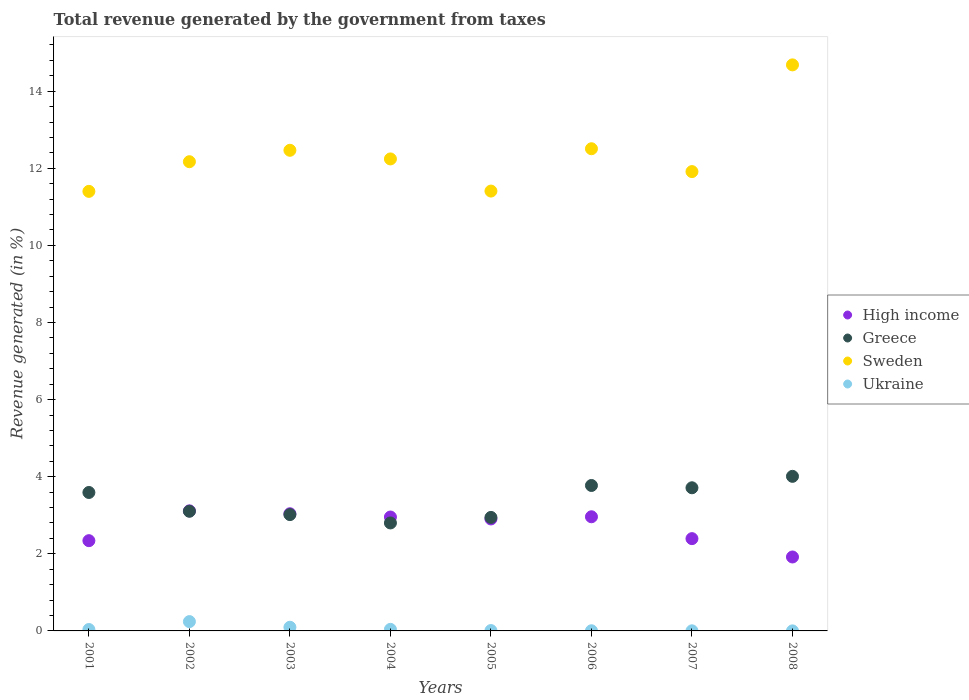How many different coloured dotlines are there?
Ensure brevity in your answer.  4. Is the number of dotlines equal to the number of legend labels?
Make the answer very short. Yes. What is the total revenue generated in High income in 2006?
Offer a very short reply. 2.96. Across all years, what is the maximum total revenue generated in Ukraine?
Make the answer very short. 0.24. Across all years, what is the minimum total revenue generated in Ukraine?
Ensure brevity in your answer.  0. In which year was the total revenue generated in Greece minimum?
Offer a very short reply. 2004. What is the total total revenue generated in Ukraine in the graph?
Ensure brevity in your answer.  0.43. What is the difference between the total revenue generated in Greece in 2002 and that in 2003?
Provide a succinct answer. 0.09. What is the difference between the total revenue generated in Greece in 2003 and the total revenue generated in Sweden in 2005?
Offer a terse response. -8.39. What is the average total revenue generated in Ukraine per year?
Keep it short and to the point. 0.05. In the year 2002, what is the difference between the total revenue generated in Greece and total revenue generated in Ukraine?
Your answer should be very brief. 2.86. In how many years, is the total revenue generated in Sweden greater than 8 %?
Give a very brief answer. 8. What is the ratio of the total revenue generated in Sweden in 2004 to that in 2005?
Provide a short and direct response. 1.07. Is the total revenue generated in High income in 2002 less than that in 2003?
Keep it short and to the point. No. Is the difference between the total revenue generated in Greece in 2002 and 2003 greater than the difference between the total revenue generated in Ukraine in 2002 and 2003?
Make the answer very short. No. What is the difference between the highest and the second highest total revenue generated in Ukraine?
Provide a succinct answer. 0.15. What is the difference between the highest and the lowest total revenue generated in Ukraine?
Offer a very short reply. 0.24. In how many years, is the total revenue generated in High income greater than the average total revenue generated in High income taken over all years?
Give a very brief answer. 5. Is it the case that in every year, the sum of the total revenue generated in Ukraine and total revenue generated in Greece  is greater than the sum of total revenue generated in High income and total revenue generated in Sweden?
Offer a very short reply. Yes. Is it the case that in every year, the sum of the total revenue generated in High income and total revenue generated in Ukraine  is greater than the total revenue generated in Greece?
Your response must be concise. No. Does the total revenue generated in Greece monotonically increase over the years?
Ensure brevity in your answer.  No. Is the total revenue generated in Greece strictly greater than the total revenue generated in Sweden over the years?
Give a very brief answer. No. Is the total revenue generated in Ukraine strictly less than the total revenue generated in Greece over the years?
Your response must be concise. Yes. How many years are there in the graph?
Offer a very short reply. 8. Does the graph contain any zero values?
Your answer should be very brief. No. How many legend labels are there?
Offer a very short reply. 4. How are the legend labels stacked?
Keep it short and to the point. Vertical. What is the title of the graph?
Give a very brief answer. Total revenue generated by the government from taxes. Does "India" appear as one of the legend labels in the graph?
Ensure brevity in your answer.  No. What is the label or title of the X-axis?
Your answer should be very brief. Years. What is the label or title of the Y-axis?
Offer a very short reply. Revenue generated (in %). What is the Revenue generated (in %) in High income in 2001?
Offer a terse response. 2.34. What is the Revenue generated (in %) of Greece in 2001?
Offer a very short reply. 3.59. What is the Revenue generated (in %) of Sweden in 2001?
Your answer should be very brief. 11.4. What is the Revenue generated (in %) in Ukraine in 2001?
Your response must be concise. 0.04. What is the Revenue generated (in %) in High income in 2002?
Ensure brevity in your answer.  3.11. What is the Revenue generated (in %) of Greece in 2002?
Keep it short and to the point. 3.1. What is the Revenue generated (in %) of Sweden in 2002?
Offer a very short reply. 12.17. What is the Revenue generated (in %) of Ukraine in 2002?
Offer a terse response. 0.24. What is the Revenue generated (in %) of High income in 2003?
Provide a succinct answer. 3.04. What is the Revenue generated (in %) in Greece in 2003?
Offer a terse response. 3.02. What is the Revenue generated (in %) in Sweden in 2003?
Provide a short and direct response. 12.47. What is the Revenue generated (in %) in Ukraine in 2003?
Provide a succinct answer. 0.1. What is the Revenue generated (in %) of High income in 2004?
Keep it short and to the point. 2.95. What is the Revenue generated (in %) in Greece in 2004?
Keep it short and to the point. 2.8. What is the Revenue generated (in %) in Sweden in 2004?
Provide a short and direct response. 12.24. What is the Revenue generated (in %) of Ukraine in 2004?
Offer a very short reply. 0.04. What is the Revenue generated (in %) of High income in 2005?
Ensure brevity in your answer.  2.9. What is the Revenue generated (in %) in Greece in 2005?
Provide a succinct answer. 2.94. What is the Revenue generated (in %) of Sweden in 2005?
Your response must be concise. 11.41. What is the Revenue generated (in %) of Ukraine in 2005?
Provide a short and direct response. 0.01. What is the Revenue generated (in %) in High income in 2006?
Your answer should be very brief. 2.96. What is the Revenue generated (in %) in Greece in 2006?
Give a very brief answer. 3.77. What is the Revenue generated (in %) of Sweden in 2006?
Offer a very short reply. 12.51. What is the Revenue generated (in %) of Ukraine in 2006?
Your response must be concise. 0. What is the Revenue generated (in %) of High income in 2007?
Ensure brevity in your answer.  2.39. What is the Revenue generated (in %) of Greece in 2007?
Your answer should be very brief. 3.71. What is the Revenue generated (in %) of Sweden in 2007?
Make the answer very short. 11.91. What is the Revenue generated (in %) in Ukraine in 2007?
Provide a short and direct response. 0. What is the Revenue generated (in %) in High income in 2008?
Ensure brevity in your answer.  1.92. What is the Revenue generated (in %) in Greece in 2008?
Provide a succinct answer. 4.01. What is the Revenue generated (in %) of Sweden in 2008?
Provide a succinct answer. 14.68. What is the Revenue generated (in %) in Ukraine in 2008?
Keep it short and to the point. 0. Across all years, what is the maximum Revenue generated (in %) of High income?
Provide a succinct answer. 3.11. Across all years, what is the maximum Revenue generated (in %) of Greece?
Offer a very short reply. 4.01. Across all years, what is the maximum Revenue generated (in %) in Sweden?
Your answer should be very brief. 14.68. Across all years, what is the maximum Revenue generated (in %) of Ukraine?
Provide a succinct answer. 0.24. Across all years, what is the minimum Revenue generated (in %) in High income?
Make the answer very short. 1.92. Across all years, what is the minimum Revenue generated (in %) in Greece?
Provide a short and direct response. 2.8. Across all years, what is the minimum Revenue generated (in %) in Sweden?
Ensure brevity in your answer.  11.4. Across all years, what is the minimum Revenue generated (in %) in Ukraine?
Your answer should be very brief. 0. What is the total Revenue generated (in %) of High income in the graph?
Give a very brief answer. 21.63. What is the total Revenue generated (in %) of Greece in the graph?
Offer a very short reply. 26.95. What is the total Revenue generated (in %) in Sweden in the graph?
Ensure brevity in your answer.  98.8. What is the total Revenue generated (in %) of Ukraine in the graph?
Offer a very short reply. 0.43. What is the difference between the Revenue generated (in %) in High income in 2001 and that in 2002?
Offer a very short reply. -0.77. What is the difference between the Revenue generated (in %) in Greece in 2001 and that in 2002?
Your answer should be very brief. 0.49. What is the difference between the Revenue generated (in %) in Sweden in 2001 and that in 2002?
Your response must be concise. -0.77. What is the difference between the Revenue generated (in %) in Ukraine in 2001 and that in 2002?
Offer a very short reply. -0.21. What is the difference between the Revenue generated (in %) in High income in 2001 and that in 2003?
Offer a very short reply. -0.7. What is the difference between the Revenue generated (in %) in Greece in 2001 and that in 2003?
Give a very brief answer. 0.57. What is the difference between the Revenue generated (in %) of Sweden in 2001 and that in 2003?
Offer a terse response. -1.07. What is the difference between the Revenue generated (in %) in Ukraine in 2001 and that in 2003?
Give a very brief answer. -0.06. What is the difference between the Revenue generated (in %) of High income in 2001 and that in 2004?
Make the answer very short. -0.61. What is the difference between the Revenue generated (in %) of Greece in 2001 and that in 2004?
Keep it short and to the point. 0.79. What is the difference between the Revenue generated (in %) in Sweden in 2001 and that in 2004?
Offer a terse response. -0.84. What is the difference between the Revenue generated (in %) in Ukraine in 2001 and that in 2004?
Offer a terse response. -0. What is the difference between the Revenue generated (in %) in High income in 2001 and that in 2005?
Your response must be concise. -0.56. What is the difference between the Revenue generated (in %) of Greece in 2001 and that in 2005?
Make the answer very short. 0.65. What is the difference between the Revenue generated (in %) in Sweden in 2001 and that in 2005?
Offer a terse response. -0.01. What is the difference between the Revenue generated (in %) in Ukraine in 2001 and that in 2005?
Make the answer very short. 0.03. What is the difference between the Revenue generated (in %) in High income in 2001 and that in 2006?
Ensure brevity in your answer.  -0.62. What is the difference between the Revenue generated (in %) of Greece in 2001 and that in 2006?
Keep it short and to the point. -0.18. What is the difference between the Revenue generated (in %) in Sweden in 2001 and that in 2006?
Provide a short and direct response. -1.11. What is the difference between the Revenue generated (in %) in Ukraine in 2001 and that in 2006?
Offer a terse response. 0.03. What is the difference between the Revenue generated (in %) of High income in 2001 and that in 2007?
Keep it short and to the point. -0.05. What is the difference between the Revenue generated (in %) in Greece in 2001 and that in 2007?
Your answer should be compact. -0.12. What is the difference between the Revenue generated (in %) in Sweden in 2001 and that in 2007?
Give a very brief answer. -0.51. What is the difference between the Revenue generated (in %) in Ukraine in 2001 and that in 2007?
Offer a terse response. 0.03. What is the difference between the Revenue generated (in %) of High income in 2001 and that in 2008?
Give a very brief answer. 0.42. What is the difference between the Revenue generated (in %) of Greece in 2001 and that in 2008?
Ensure brevity in your answer.  -0.42. What is the difference between the Revenue generated (in %) of Sweden in 2001 and that in 2008?
Your response must be concise. -3.28. What is the difference between the Revenue generated (in %) of Ukraine in 2001 and that in 2008?
Your answer should be compact. 0.04. What is the difference between the Revenue generated (in %) in High income in 2002 and that in 2003?
Your answer should be very brief. 0.08. What is the difference between the Revenue generated (in %) of Greece in 2002 and that in 2003?
Your answer should be compact. 0.09. What is the difference between the Revenue generated (in %) of Sweden in 2002 and that in 2003?
Keep it short and to the point. -0.3. What is the difference between the Revenue generated (in %) of Ukraine in 2002 and that in 2003?
Provide a succinct answer. 0.15. What is the difference between the Revenue generated (in %) in High income in 2002 and that in 2004?
Provide a short and direct response. 0.16. What is the difference between the Revenue generated (in %) of Greece in 2002 and that in 2004?
Ensure brevity in your answer.  0.3. What is the difference between the Revenue generated (in %) of Sweden in 2002 and that in 2004?
Offer a terse response. -0.07. What is the difference between the Revenue generated (in %) in Ukraine in 2002 and that in 2004?
Give a very brief answer. 0.2. What is the difference between the Revenue generated (in %) in High income in 2002 and that in 2005?
Offer a very short reply. 0.21. What is the difference between the Revenue generated (in %) in Greece in 2002 and that in 2005?
Give a very brief answer. 0.16. What is the difference between the Revenue generated (in %) of Sweden in 2002 and that in 2005?
Ensure brevity in your answer.  0.76. What is the difference between the Revenue generated (in %) of Ukraine in 2002 and that in 2005?
Your answer should be compact. 0.23. What is the difference between the Revenue generated (in %) of High income in 2002 and that in 2006?
Your response must be concise. 0.15. What is the difference between the Revenue generated (in %) of Greece in 2002 and that in 2006?
Offer a very short reply. -0.67. What is the difference between the Revenue generated (in %) in Sweden in 2002 and that in 2006?
Ensure brevity in your answer.  -0.34. What is the difference between the Revenue generated (in %) of Ukraine in 2002 and that in 2006?
Keep it short and to the point. 0.24. What is the difference between the Revenue generated (in %) of High income in 2002 and that in 2007?
Provide a succinct answer. 0.72. What is the difference between the Revenue generated (in %) in Greece in 2002 and that in 2007?
Provide a short and direct response. -0.61. What is the difference between the Revenue generated (in %) in Sweden in 2002 and that in 2007?
Your answer should be very brief. 0.26. What is the difference between the Revenue generated (in %) of Ukraine in 2002 and that in 2007?
Your answer should be very brief. 0.24. What is the difference between the Revenue generated (in %) in High income in 2002 and that in 2008?
Your answer should be very brief. 1.2. What is the difference between the Revenue generated (in %) in Greece in 2002 and that in 2008?
Provide a succinct answer. -0.91. What is the difference between the Revenue generated (in %) in Sweden in 2002 and that in 2008?
Provide a short and direct response. -2.51. What is the difference between the Revenue generated (in %) in Ukraine in 2002 and that in 2008?
Keep it short and to the point. 0.24. What is the difference between the Revenue generated (in %) of High income in 2003 and that in 2004?
Keep it short and to the point. 0.09. What is the difference between the Revenue generated (in %) of Greece in 2003 and that in 2004?
Provide a succinct answer. 0.22. What is the difference between the Revenue generated (in %) in Sweden in 2003 and that in 2004?
Offer a terse response. 0.22. What is the difference between the Revenue generated (in %) in Ukraine in 2003 and that in 2004?
Keep it short and to the point. 0.05. What is the difference between the Revenue generated (in %) of High income in 2003 and that in 2005?
Your answer should be compact. 0.14. What is the difference between the Revenue generated (in %) of Greece in 2003 and that in 2005?
Provide a succinct answer. 0.07. What is the difference between the Revenue generated (in %) of Sweden in 2003 and that in 2005?
Your answer should be very brief. 1.06. What is the difference between the Revenue generated (in %) of Ukraine in 2003 and that in 2005?
Keep it short and to the point. 0.09. What is the difference between the Revenue generated (in %) in High income in 2003 and that in 2006?
Provide a succinct answer. 0.08. What is the difference between the Revenue generated (in %) in Greece in 2003 and that in 2006?
Provide a succinct answer. -0.76. What is the difference between the Revenue generated (in %) in Sweden in 2003 and that in 2006?
Your answer should be compact. -0.04. What is the difference between the Revenue generated (in %) of Ukraine in 2003 and that in 2006?
Keep it short and to the point. 0.09. What is the difference between the Revenue generated (in %) in High income in 2003 and that in 2007?
Your answer should be very brief. 0.65. What is the difference between the Revenue generated (in %) in Greece in 2003 and that in 2007?
Provide a succinct answer. -0.7. What is the difference between the Revenue generated (in %) of Sweden in 2003 and that in 2007?
Provide a short and direct response. 0.55. What is the difference between the Revenue generated (in %) of Ukraine in 2003 and that in 2007?
Ensure brevity in your answer.  0.09. What is the difference between the Revenue generated (in %) of High income in 2003 and that in 2008?
Ensure brevity in your answer.  1.12. What is the difference between the Revenue generated (in %) in Greece in 2003 and that in 2008?
Your answer should be compact. -0.99. What is the difference between the Revenue generated (in %) in Sweden in 2003 and that in 2008?
Ensure brevity in your answer.  -2.22. What is the difference between the Revenue generated (in %) of Ukraine in 2003 and that in 2008?
Your response must be concise. 0.09. What is the difference between the Revenue generated (in %) of High income in 2004 and that in 2005?
Ensure brevity in your answer.  0.05. What is the difference between the Revenue generated (in %) of Greece in 2004 and that in 2005?
Offer a terse response. -0.14. What is the difference between the Revenue generated (in %) in Sweden in 2004 and that in 2005?
Your response must be concise. 0.83. What is the difference between the Revenue generated (in %) in Ukraine in 2004 and that in 2005?
Your answer should be very brief. 0.03. What is the difference between the Revenue generated (in %) in High income in 2004 and that in 2006?
Keep it short and to the point. -0.01. What is the difference between the Revenue generated (in %) in Greece in 2004 and that in 2006?
Offer a terse response. -0.97. What is the difference between the Revenue generated (in %) of Sweden in 2004 and that in 2006?
Ensure brevity in your answer.  -0.26. What is the difference between the Revenue generated (in %) in Ukraine in 2004 and that in 2006?
Give a very brief answer. 0.04. What is the difference between the Revenue generated (in %) in High income in 2004 and that in 2007?
Provide a short and direct response. 0.56. What is the difference between the Revenue generated (in %) in Greece in 2004 and that in 2007?
Your answer should be very brief. -0.91. What is the difference between the Revenue generated (in %) of Sweden in 2004 and that in 2007?
Your answer should be compact. 0.33. What is the difference between the Revenue generated (in %) of Ukraine in 2004 and that in 2007?
Give a very brief answer. 0.04. What is the difference between the Revenue generated (in %) of High income in 2004 and that in 2008?
Your response must be concise. 1.04. What is the difference between the Revenue generated (in %) in Greece in 2004 and that in 2008?
Keep it short and to the point. -1.21. What is the difference between the Revenue generated (in %) in Sweden in 2004 and that in 2008?
Offer a terse response. -2.44. What is the difference between the Revenue generated (in %) in Ukraine in 2004 and that in 2008?
Give a very brief answer. 0.04. What is the difference between the Revenue generated (in %) of High income in 2005 and that in 2006?
Your response must be concise. -0.06. What is the difference between the Revenue generated (in %) of Greece in 2005 and that in 2006?
Offer a terse response. -0.83. What is the difference between the Revenue generated (in %) of Sweden in 2005 and that in 2006?
Keep it short and to the point. -1.1. What is the difference between the Revenue generated (in %) in Ukraine in 2005 and that in 2006?
Your answer should be compact. 0.01. What is the difference between the Revenue generated (in %) in High income in 2005 and that in 2007?
Offer a very short reply. 0.51. What is the difference between the Revenue generated (in %) in Greece in 2005 and that in 2007?
Make the answer very short. -0.77. What is the difference between the Revenue generated (in %) of Sweden in 2005 and that in 2007?
Provide a succinct answer. -0.51. What is the difference between the Revenue generated (in %) of Ukraine in 2005 and that in 2007?
Provide a short and direct response. 0.01. What is the difference between the Revenue generated (in %) in High income in 2005 and that in 2008?
Ensure brevity in your answer.  0.99. What is the difference between the Revenue generated (in %) of Greece in 2005 and that in 2008?
Offer a terse response. -1.07. What is the difference between the Revenue generated (in %) of Sweden in 2005 and that in 2008?
Make the answer very short. -3.27. What is the difference between the Revenue generated (in %) of Ukraine in 2005 and that in 2008?
Your answer should be very brief. 0.01. What is the difference between the Revenue generated (in %) of High income in 2006 and that in 2007?
Offer a terse response. 0.57. What is the difference between the Revenue generated (in %) in Greece in 2006 and that in 2007?
Provide a succinct answer. 0.06. What is the difference between the Revenue generated (in %) in Sweden in 2006 and that in 2007?
Your answer should be compact. 0.59. What is the difference between the Revenue generated (in %) in Ukraine in 2006 and that in 2007?
Your response must be concise. 0. What is the difference between the Revenue generated (in %) in High income in 2006 and that in 2008?
Give a very brief answer. 1.04. What is the difference between the Revenue generated (in %) in Greece in 2006 and that in 2008?
Your response must be concise. -0.24. What is the difference between the Revenue generated (in %) in Sweden in 2006 and that in 2008?
Make the answer very short. -2.18. What is the difference between the Revenue generated (in %) in Ukraine in 2006 and that in 2008?
Offer a terse response. 0. What is the difference between the Revenue generated (in %) of High income in 2007 and that in 2008?
Keep it short and to the point. 0.48. What is the difference between the Revenue generated (in %) of Greece in 2007 and that in 2008?
Ensure brevity in your answer.  -0.3. What is the difference between the Revenue generated (in %) of Sweden in 2007 and that in 2008?
Keep it short and to the point. -2.77. What is the difference between the Revenue generated (in %) in Ukraine in 2007 and that in 2008?
Ensure brevity in your answer.  0. What is the difference between the Revenue generated (in %) of High income in 2001 and the Revenue generated (in %) of Greece in 2002?
Your answer should be compact. -0.76. What is the difference between the Revenue generated (in %) in High income in 2001 and the Revenue generated (in %) in Sweden in 2002?
Keep it short and to the point. -9.83. What is the difference between the Revenue generated (in %) in High income in 2001 and the Revenue generated (in %) in Ukraine in 2002?
Make the answer very short. 2.1. What is the difference between the Revenue generated (in %) of Greece in 2001 and the Revenue generated (in %) of Sweden in 2002?
Your response must be concise. -8.58. What is the difference between the Revenue generated (in %) in Greece in 2001 and the Revenue generated (in %) in Ukraine in 2002?
Provide a succinct answer. 3.35. What is the difference between the Revenue generated (in %) of Sweden in 2001 and the Revenue generated (in %) of Ukraine in 2002?
Keep it short and to the point. 11.16. What is the difference between the Revenue generated (in %) in High income in 2001 and the Revenue generated (in %) in Greece in 2003?
Your answer should be compact. -0.68. What is the difference between the Revenue generated (in %) of High income in 2001 and the Revenue generated (in %) of Sweden in 2003?
Your response must be concise. -10.13. What is the difference between the Revenue generated (in %) of High income in 2001 and the Revenue generated (in %) of Ukraine in 2003?
Your answer should be very brief. 2.25. What is the difference between the Revenue generated (in %) of Greece in 2001 and the Revenue generated (in %) of Sweden in 2003?
Your answer should be very brief. -8.88. What is the difference between the Revenue generated (in %) of Greece in 2001 and the Revenue generated (in %) of Ukraine in 2003?
Make the answer very short. 3.5. What is the difference between the Revenue generated (in %) in Sweden in 2001 and the Revenue generated (in %) in Ukraine in 2003?
Ensure brevity in your answer.  11.31. What is the difference between the Revenue generated (in %) in High income in 2001 and the Revenue generated (in %) in Greece in 2004?
Offer a terse response. -0.46. What is the difference between the Revenue generated (in %) in High income in 2001 and the Revenue generated (in %) in Sweden in 2004?
Keep it short and to the point. -9.9. What is the difference between the Revenue generated (in %) of High income in 2001 and the Revenue generated (in %) of Ukraine in 2004?
Your response must be concise. 2.3. What is the difference between the Revenue generated (in %) in Greece in 2001 and the Revenue generated (in %) in Sweden in 2004?
Your answer should be compact. -8.65. What is the difference between the Revenue generated (in %) of Greece in 2001 and the Revenue generated (in %) of Ukraine in 2004?
Give a very brief answer. 3.55. What is the difference between the Revenue generated (in %) in Sweden in 2001 and the Revenue generated (in %) in Ukraine in 2004?
Make the answer very short. 11.36. What is the difference between the Revenue generated (in %) in High income in 2001 and the Revenue generated (in %) in Greece in 2005?
Ensure brevity in your answer.  -0.6. What is the difference between the Revenue generated (in %) in High income in 2001 and the Revenue generated (in %) in Sweden in 2005?
Offer a terse response. -9.07. What is the difference between the Revenue generated (in %) of High income in 2001 and the Revenue generated (in %) of Ukraine in 2005?
Provide a short and direct response. 2.33. What is the difference between the Revenue generated (in %) of Greece in 2001 and the Revenue generated (in %) of Sweden in 2005?
Make the answer very short. -7.82. What is the difference between the Revenue generated (in %) in Greece in 2001 and the Revenue generated (in %) in Ukraine in 2005?
Offer a terse response. 3.58. What is the difference between the Revenue generated (in %) in Sweden in 2001 and the Revenue generated (in %) in Ukraine in 2005?
Offer a very short reply. 11.39. What is the difference between the Revenue generated (in %) of High income in 2001 and the Revenue generated (in %) of Greece in 2006?
Your response must be concise. -1.43. What is the difference between the Revenue generated (in %) of High income in 2001 and the Revenue generated (in %) of Sweden in 2006?
Your response must be concise. -10.17. What is the difference between the Revenue generated (in %) of High income in 2001 and the Revenue generated (in %) of Ukraine in 2006?
Your answer should be compact. 2.34. What is the difference between the Revenue generated (in %) in Greece in 2001 and the Revenue generated (in %) in Sweden in 2006?
Your response must be concise. -8.92. What is the difference between the Revenue generated (in %) of Greece in 2001 and the Revenue generated (in %) of Ukraine in 2006?
Provide a short and direct response. 3.59. What is the difference between the Revenue generated (in %) of Sweden in 2001 and the Revenue generated (in %) of Ukraine in 2006?
Offer a very short reply. 11.4. What is the difference between the Revenue generated (in %) of High income in 2001 and the Revenue generated (in %) of Greece in 2007?
Provide a succinct answer. -1.37. What is the difference between the Revenue generated (in %) in High income in 2001 and the Revenue generated (in %) in Sweden in 2007?
Offer a terse response. -9.57. What is the difference between the Revenue generated (in %) of High income in 2001 and the Revenue generated (in %) of Ukraine in 2007?
Provide a succinct answer. 2.34. What is the difference between the Revenue generated (in %) in Greece in 2001 and the Revenue generated (in %) in Sweden in 2007?
Your response must be concise. -8.32. What is the difference between the Revenue generated (in %) in Greece in 2001 and the Revenue generated (in %) in Ukraine in 2007?
Your response must be concise. 3.59. What is the difference between the Revenue generated (in %) in Sweden in 2001 and the Revenue generated (in %) in Ukraine in 2007?
Keep it short and to the point. 11.4. What is the difference between the Revenue generated (in %) of High income in 2001 and the Revenue generated (in %) of Greece in 2008?
Your response must be concise. -1.67. What is the difference between the Revenue generated (in %) of High income in 2001 and the Revenue generated (in %) of Sweden in 2008?
Offer a very short reply. -12.34. What is the difference between the Revenue generated (in %) of High income in 2001 and the Revenue generated (in %) of Ukraine in 2008?
Keep it short and to the point. 2.34. What is the difference between the Revenue generated (in %) of Greece in 2001 and the Revenue generated (in %) of Sweden in 2008?
Your response must be concise. -11.09. What is the difference between the Revenue generated (in %) of Greece in 2001 and the Revenue generated (in %) of Ukraine in 2008?
Your answer should be very brief. 3.59. What is the difference between the Revenue generated (in %) in Sweden in 2001 and the Revenue generated (in %) in Ukraine in 2008?
Make the answer very short. 11.4. What is the difference between the Revenue generated (in %) of High income in 2002 and the Revenue generated (in %) of Greece in 2003?
Ensure brevity in your answer.  0.1. What is the difference between the Revenue generated (in %) of High income in 2002 and the Revenue generated (in %) of Sweden in 2003?
Your answer should be very brief. -9.35. What is the difference between the Revenue generated (in %) of High income in 2002 and the Revenue generated (in %) of Ukraine in 2003?
Offer a terse response. 3.02. What is the difference between the Revenue generated (in %) in Greece in 2002 and the Revenue generated (in %) in Sweden in 2003?
Offer a terse response. -9.36. What is the difference between the Revenue generated (in %) in Greece in 2002 and the Revenue generated (in %) in Ukraine in 2003?
Keep it short and to the point. 3.01. What is the difference between the Revenue generated (in %) in Sweden in 2002 and the Revenue generated (in %) in Ukraine in 2003?
Offer a very short reply. 12.08. What is the difference between the Revenue generated (in %) of High income in 2002 and the Revenue generated (in %) of Greece in 2004?
Keep it short and to the point. 0.31. What is the difference between the Revenue generated (in %) in High income in 2002 and the Revenue generated (in %) in Sweden in 2004?
Your answer should be compact. -9.13. What is the difference between the Revenue generated (in %) of High income in 2002 and the Revenue generated (in %) of Ukraine in 2004?
Your answer should be very brief. 3.07. What is the difference between the Revenue generated (in %) of Greece in 2002 and the Revenue generated (in %) of Sweden in 2004?
Offer a very short reply. -9.14. What is the difference between the Revenue generated (in %) of Greece in 2002 and the Revenue generated (in %) of Ukraine in 2004?
Your response must be concise. 3.06. What is the difference between the Revenue generated (in %) of Sweden in 2002 and the Revenue generated (in %) of Ukraine in 2004?
Provide a short and direct response. 12.13. What is the difference between the Revenue generated (in %) of High income in 2002 and the Revenue generated (in %) of Greece in 2005?
Ensure brevity in your answer.  0.17. What is the difference between the Revenue generated (in %) of High income in 2002 and the Revenue generated (in %) of Sweden in 2005?
Provide a succinct answer. -8.29. What is the difference between the Revenue generated (in %) in High income in 2002 and the Revenue generated (in %) in Ukraine in 2005?
Keep it short and to the point. 3.11. What is the difference between the Revenue generated (in %) of Greece in 2002 and the Revenue generated (in %) of Sweden in 2005?
Offer a very short reply. -8.31. What is the difference between the Revenue generated (in %) of Greece in 2002 and the Revenue generated (in %) of Ukraine in 2005?
Make the answer very short. 3.09. What is the difference between the Revenue generated (in %) of Sweden in 2002 and the Revenue generated (in %) of Ukraine in 2005?
Keep it short and to the point. 12.16. What is the difference between the Revenue generated (in %) of High income in 2002 and the Revenue generated (in %) of Greece in 2006?
Ensure brevity in your answer.  -0.66. What is the difference between the Revenue generated (in %) of High income in 2002 and the Revenue generated (in %) of Sweden in 2006?
Your answer should be compact. -9.39. What is the difference between the Revenue generated (in %) of High income in 2002 and the Revenue generated (in %) of Ukraine in 2006?
Your answer should be very brief. 3.11. What is the difference between the Revenue generated (in %) in Greece in 2002 and the Revenue generated (in %) in Sweden in 2006?
Ensure brevity in your answer.  -9.4. What is the difference between the Revenue generated (in %) in Greece in 2002 and the Revenue generated (in %) in Ukraine in 2006?
Offer a terse response. 3.1. What is the difference between the Revenue generated (in %) in Sweden in 2002 and the Revenue generated (in %) in Ukraine in 2006?
Ensure brevity in your answer.  12.17. What is the difference between the Revenue generated (in %) of High income in 2002 and the Revenue generated (in %) of Greece in 2007?
Ensure brevity in your answer.  -0.6. What is the difference between the Revenue generated (in %) in High income in 2002 and the Revenue generated (in %) in Sweden in 2007?
Provide a succinct answer. -8.8. What is the difference between the Revenue generated (in %) in High income in 2002 and the Revenue generated (in %) in Ukraine in 2007?
Provide a short and direct response. 3.11. What is the difference between the Revenue generated (in %) in Greece in 2002 and the Revenue generated (in %) in Sweden in 2007?
Offer a very short reply. -8.81. What is the difference between the Revenue generated (in %) in Greece in 2002 and the Revenue generated (in %) in Ukraine in 2007?
Ensure brevity in your answer.  3.1. What is the difference between the Revenue generated (in %) of Sweden in 2002 and the Revenue generated (in %) of Ukraine in 2007?
Keep it short and to the point. 12.17. What is the difference between the Revenue generated (in %) in High income in 2002 and the Revenue generated (in %) in Greece in 2008?
Provide a short and direct response. -0.9. What is the difference between the Revenue generated (in %) in High income in 2002 and the Revenue generated (in %) in Sweden in 2008?
Keep it short and to the point. -11.57. What is the difference between the Revenue generated (in %) in High income in 2002 and the Revenue generated (in %) in Ukraine in 2008?
Provide a succinct answer. 3.11. What is the difference between the Revenue generated (in %) in Greece in 2002 and the Revenue generated (in %) in Sweden in 2008?
Give a very brief answer. -11.58. What is the difference between the Revenue generated (in %) of Greece in 2002 and the Revenue generated (in %) of Ukraine in 2008?
Ensure brevity in your answer.  3.1. What is the difference between the Revenue generated (in %) of Sweden in 2002 and the Revenue generated (in %) of Ukraine in 2008?
Your answer should be compact. 12.17. What is the difference between the Revenue generated (in %) in High income in 2003 and the Revenue generated (in %) in Greece in 2004?
Make the answer very short. 0.24. What is the difference between the Revenue generated (in %) in High income in 2003 and the Revenue generated (in %) in Sweden in 2004?
Provide a short and direct response. -9.2. What is the difference between the Revenue generated (in %) of High income in 2003 and the Revenue generated (in %) of Ukraine in 2004?
Make the answer very short. 3. What is the difference between the Revenue generated (in %) of Greece in 2003 and the Revenue generated (in %) of Sweden in 2004?
Ensure brevity in your answer.  -9.23. What is the difference between the Revenue generated (in %) in Greece in 2003 and the Revenue generated (in %) in Ukraine in 2004?
Your answer should be compact. 2.98. What is the difference between the Revenue generated (in %) in Sweden in 2003 and the Revenue generated (in %) in Ukraine in 2004?
Your response must be concise. 12.43. What is the difference between the Revenue generated (in %) of High income in 2003 and the Revenue generated (in %) of Greece in 2005?
Your answer should be compact. 0.1. What is the difference between the Revenue generated (in %) of High income in 2003 and the Revenue generated (in %) of Sweden in 2005?
Keep it short and to the point. -8.37. What is the difference between the Revenue generated (in %) of High income in 2003 and the Revenue generated (in %) of Ukraine in 2005?
Provide a short and direct response. 3.03. What is the difference between the Revenue generated (in %) in Greece in 2003 and the Revenue generated (in %) in Sweden in 2005?
Your answer should be compact. -8.39. What is the difference between the Revenue generated (in %) of Greece in 2003 and the Revenue generated (in %) of Ukraine in 2005?
Your answer should be very brief. 3.01. What is the difference between the Revenue generated (in %) in Sweden in 2003 and the Revenue generated (in %) in Ukraine in 2005?
Your answer should be very brief. 12.46. What is the difference between the Revenue generated (in %) in High income in 2003 and the Revenue generated (in %) in Greece in 2006?
Ensure brevity in your answer.  -0.73. What is the difference between the Revenue generated (in %) in High income in 2003 and the Revenue generated (in %) in Sweden in 2006?
Your response must be concise. -9.47. What is the difference between the Revenue generated (in %) in High income in 2003 and the Revenue generated (in %) in Ukraine in 2006?
Your response must be concise. 3.04. What is the difference between the Revenue generated (in %) of Greece in 2003 and the Revenue generated (in %) of Sweden in 2006?
Offer a terse response. -9.49. What is the difference between the Revenue generated (in %) of Greece in 2003 and the Revenue generated (in %) of Ukraine in 2006?
Ensure brevity in your answer.  3.01. What is the difference between the Revenue generated (in %) in Sweden in 2003 and the Revenue generated (in %) in Ukraine in 2006?
Your answer should be compact. 12.46. What is the difference between the Revenue generated (in %) of High income in 2003 and the Revenue generated (in %) of Greece in 2007?
Provide a succinct answer. -0.67. What is the difference between the Revenue generated (in %) in High income in 2003 and the Revenue generated (in %) in Sweden in 2007?
Your answer should be very brief. -8.87. What is the difference between the Revenue generated (in %) in High income in 2003 and the Revenue generated (in %) in Ukraine in 2007?
Provide a succinct answer. 3.04. What is the difference between the Revenue generated (in %) in Greece in 2003 and the Revenue generated (in %) in Sweden in 2007?
Keep it short and to the point. -8.9. What is the difference between the Revenue generated (in %) in Greece in 2003 and the Revenue generated (in %) in Ukraine in 2007?
Make the answer very short. 3.01. What is the difference between the Revenue generated (in %) of Sweden in 2003 and the Revenue generated (in %) of Ukraine in 2007?
Your answer should be compact. 12.46. What is the difference between the Revenue generated (in %) of High income in 2003 and the Revenue generated (in %) of Greece in 2008?
Offer a very short reply. -0.97. What is the difference between the Revenue generated (in %) in High income in 2003 and the Revenue generated (in %) in Sweden in 2008?
Make the answer very short. -11.64. What is the difference between the Revenue generated (in %) in High income in 2003 and the Revenue generated (in %) in Ukraine in 2008?
Offer a very short reply. 3.04. What is the difference between the Revenue generated (in %) in Greece in 2003 and the Revenue generated (in %) in Sweden in 2008?
Your response must be concise. -11.67. What is the difference between the Revenue generated (in %) of Greece in 2003 and the Revenue generated (in %) of Ukraine in 2008?
Ensure brevity in your answer.  3.02. What is the difference between the Revenue generated (in %) of Sweden in 2003 and the Revenue generated (in %) of Ukraine in 2008?
Ensure brevity in your answer.  12.47. What is the difference between the Revenue generated (in %) of High income in 2004 and the Revenue generated (in %) of Greece in 2005?
Make the answer very short. 0.01. What is the difference between the Revenue generated (in %) in High income in 2004 and the Revenue generated (in %) in Sweden in 2005?
Offer a terse response. -8.45. What is the difference between the Revenue generated (in %) of High income in 2004 and the Revenue generated (in %) of Ukraine in 2005?
Offer a terse response. 2.95. What is the difference between the Revenue generated (in %) of Greece in 2004 and the Revenue generated (in %) of Sweden in 2005?
Ensure brevity in your answer.  -8.61. What is the difference between the Revenue generated (in %) of Greece in 2004 and the Revenue generated (in %) of Ukraine in 2005?
Keep it short and to the point. 2.79. What is the difference between the Revenue generated (in %) in Sweden in 2004 and the Revenue generated (in %) in Ukraine in 2005?
Give a very brief answer. 12.23. What is the difference between the Revenue generated (in %) of High income in 2004 and the Revenue generated (in %) of Greece in 2006?
Provide a short and direct response. -0.82. What is the difference between the Revenue generated (in %) of High income in 2004 and the Revenue generated (in %) of Sweden in 2006?
Your answer should be compact. -9.55. What is the difference between the Revenue generated (in %) in High income in 2004 and the Revenue generated (in %) in Ukraine in 2006?
Your response must be concise. 2.95. What is the difference between the Revenue generated (in %) of Greece in 2004 and the Revenue generated (in %) of Sweden in 2006?
Your answer should be very brief. -9.71. What is the difference between the Revenue generated (in %) in Greece in 2004 and the Revenue generated (in %) in Ukraine in 2006?
Keep it short and to the point. 2.8. What is the difference between the Revenue generated (in %) in Sweden in 2004 and the Revenue generated (in %) in Ukraine in 2006?
Make the answer very short. 12.24. What is the difference between the Revenue generated (in %) of High income in 2004 and the Revenue generated (in %) of Greece in 2007?
Ensure brevity in your answer.  -0.76. What is the difference between the Revenue generated (in %) of High income in 2004 and the Revenue generated (in %) of Sweden in 2007?
Make the answer very short. -8.96. What is the difference between the Revenue generated (in %) of High income in 2004 and the Revenue generated (in %) of Ukraine in 2007?
Offer a terse response. 2.95. What is the difference between the Revenue generated (in %) in Greece in 2004 and the Revenue generated (in %) in Sweden in 2007?
Provide a succinct answer. -9.11. What is the difference between the Revenue generated (in %) in Greece in 2004 and the Revenue generated (in %) in Ukraine in 2007?
Keep it short and to the point. 2.8. What is the difference between the Revenue generated (in %) of Sweden in 2004 and the Revenue generated (in %) of Ukraine in 2007?
Offer a very short reply. 12.24. What is the difference between the Revenue generated (in %) in High income in 2004 and the Revenue generated (in %) in Greece in 2008?
Provide a short and direct response. -1.06. What is the difference between the Revenue generated (in %) in High income in 2004 and the Revenue generated (in %) in Sweden in 2008?
Your answer should be very brief. -11.73. What is the difference between the Revenue generated (in %) in High income in 2004 and the Revenue generated (in %) in Ukraine in 2008?
Provide a short and direct response. 2.95. What is the difference between the Revenue generated (in %) in Greece in 2004 and the Revenue generated (in %) in Sweden in 2008?
Keep it short and to the point. -11.88. What is the difference between the Revenue generated (in %) in Greece in 2004 and the Revenue generated (in %) in Ukraine in 2008?
Give a very brief answer. 2.8. What is the difference between the Revenue generated (in %) in Sweden in 2004 and the Revenue generated (in %) in Ukraine in 2008?
Offer a very short reply. 12.24. What is the difference between the Revenue generated (in %) in High income in 2005 and the Revenue generated (in %) in Greece in 2006?
Keep it short and to the point. -0.87. What is the difference between the Revenue generated (in %) of High income in 2005 and the Revenue generated (in %) of Sweden in 2006?
Provide a short and direct response. -9.6. What is the difference between the Revenue generated (in %) in Greece in 2005 and the Revenue generated (in %) in Sweden in 2006?
Make the answer very short. -9.56. What is the difference between the Revenue generated (in %) of Greece in 2005 and the Revenue generated (in %) of Ukraine in 2006?
Provide a succinct answer. 2.94. What is the difference between the Revenue generated (in %) in Sweden in 2005 and the Revenue generated (in %) in Ukraine in 2006?
Offer a very short reply. 11.41. What is the difference between the Revenue generated (in %) in High income in 2005 and the Revenue generated (in %) in Greece in 2007?
Make the answer very short. -0.81. What is the difference between the Revenue generated (in %) of High income in 2005 and the Revenue generated (in %) of Sweden in 2007?
Give a very brief answer. -9.01. What is the difference between the Revenue generated (in %) in High income in 2005 and the Revenue generated (in %) in Ukraine in 2007?
Your answer should be compact. 2.9. What is the difference between the Revenue generated (in %) of Greece in 2005 and the Revenue generated (in %) of Sweden in 2007?
Your answer should be very brief. -8.97. What is the difference between the Revenue generated (in %) in Greece in 2005 and the Revenue generated (in %) in Ukraine in 2007?
Keep it short and to the point. 2.94. What is the difference between the Revenue generated (in %) in Sweden in 2005 and the Revenue generated (in %) in Ukraine in 2007?
Make the answer very short. 11.41. What is the difference between the Revenue generated (in %) in High income in 2005 and the Revenue generated (in %) in Greece in 2008?
Provide a short and direct response. -1.11. What is the difference between the Revenue generated (in %) of High income in 2005 and the Revenue generated (in %) of Sweden in 2008?
Make the answer very short. -11.78. What is the difference between the Revenue generated (in %) of High income in 2005 and the Revenue generated (in %) of Ukraine in 2008?
Your response must be concise. 2.9. What is the difference between the Revenue generated (in %) of Greece in 2005 and the Revenue generated (in %) of Sweden in 2008?
Provide a succinct answer. -11.74. What is the difference between the Revenue generated (in %) in Greece in 2005 and the Revenue generated (in %) in Ukraine in 2008?
Give a very brief answer. 2.94. What is the difference between the Revenue generated (in %) in Sweden in 2005 and the Revenue generated (in %) in Ukraine in 2008?
Provide a succinct answer. 11.41. What is the difference between the Revenue generated (in %) in High income in 2006 and the Revenue generated (in %) in Greece in 2007?
Make the answer very short. -0.75. What is the difference between the Revenue generated (in %) of High income in 2006 and the Revenue generated (in %) of Sweden in 2007?
Ensure brevity in your answer.  -8.95. What is the difference between the Revenue generated (in %) of High income in 2006 and the Revenue generated (in %) of Ukraine in 2007?
Make the answer very short. 2.96. What is the difference between the Revenue generated (in %) of Greece in 2006 and the Revenue generated (in %) of Sweden in 2007?
Make the answer very short. -8.14. What is the difference between the Revenue generated (in %) of Greece in 2006 and the Revenue generated (in %) of Ukraine in 2007?
Offer a very short reply. 3.77. What is the difference between the Revenue generated (in %) of Sweden in 2006 and the Revenue generated (in %) of Ukraine in 2007?
Your answer should be very brief. 12.5. What is the difference between the Revenue generated (in %) of High income in 2006 and the Revenue generated (in %) of Greece in 2008?
Offer a terse response. -1.05. What is the difference between the Revenue generated (in %) of High income in 2006 and the Revenue generated (in %) of Sweden in 2008?
Offer a terse response. -11.72. What is the difference between the Revenue generated (in %) of High income in 2006 and the Revenue generated (in %) of Ukraine in 2008?
Give a very brief answer. 2.96. What is the difference between the Revenue generated (in %) in Greece in 2006 and the Revenue generated (in %) in Sweden in 2008?
Offer a very short reply. -10.91. What is the difference between the Revenue generated (in %) in Greece in 2006 and the Revenue generated (in %) in Ukraine in 2008?
Provide a succinct answer. 3.77. What is the difference between the Revenue generated (in %) in Sweden in 2006 and the Revenue generated (in %) in Ukraine in 2008?
Ensure brevity in your answer.  12.51. What is the difference between the Revenue generated (in %) of High income in 2007 and the Revenue generated (in %) of Greece in 2008?
Offer a very short reply. -1.62. What is the difference between the Revenue generated (in %) in High income in 2007 and the Revenue generated (in %) in Sweden in 2008?
Your answer should be very brief. -12.29. What is the difference between the Revenue generated (in %) in High income in 2007 and the Revenue generated (in %) in Ukraine in 2008?
Offer a very short reply. 2.39. What is the difference between the Revenue generated (in %) in Greece in 2007 and the Revenue generated (in %) in Sweden in 2008?
Ensure brevity in your answer.  -10.97. What is the difference between the Revenue generated (in %) of Greece in 2007 and the Revenue generated (in %) of Ukraine in 2008?
Your response must be concise. 3.71. What is the difference between the Revenue generated (in %) in Sweden in 2007 and the Revenue generated (in %) in Ukraine in 2008?
Provide a short and direct response. 11.91. What is the average Revenue generated (in %) in High income per year?
Your answer should be compact. 2.7. What is the average Revenue generated (in %) of Greece per year?
Keep it short and to the point. 3.37. What is the average Revenue generated (in %) in Sweden per year?
Offer a terse response. 12.35. What is the average Revenue generated (in %) in Ukraine per year?
Make the answer very short. 0.05. In the year 2001, what is the difference between the Revenue generated (in %) of High income and Revenue generated (in %) of Greece?
Ensure brevity in your answer.  -1.25. In the year 2001, what is the difference between the Revenue generated (in %) of High income and Revenue generated (in %) of Sweden?
Make the answer very short. -9.06. In the year 2001, what is the difference between the Revenue generated (in %) of High income and Revenue generated (in %) of Ukraine?
Your answer should be compact. 2.3. In the year 2001, what is the difference between the Revenue generated (in %) in Greece and Revenue generated (in %) in Sweden?
Provide a succinct answer. -7.81. In the year 2001, what is the difference between the Revenue generated (in %) in Greece and Revenue generated (in %) in Ukraine?
Your response must be concise. 3.55. In the year 2001, what is the difference between the Revenue generated (in %) in Sweden and Revenue generated (in %) in Ukraine?
Your response must be concise. 11.37. In the year 2002, what is the difference between the Revenue generated (in %) of High income and Revenue generated (in %) of Greece?
Provide a succinct answer. 0.01. In the year 2002, what is the difference between the Revenue generated (in %) of High income and Revenue generated (in %) of Sweden?
Offer a terse response. -9.06. In the year 2002, what is the difference between the Revenue generated (in %) of High income and Revenue generated (in %) of Ukraine?
Give a very brief answer. 2.87. In the year 2002, what is the difference between the Revenue generated (in %) of Greece and Revenue generated (in %) of Sweden?
Offer a terse response. -9.07. In the year 2002, what is the difference between the Revenue generated (in %) of Greece and Revenue generated (in %) of Ukraine?
Keep it short and to the point. 2.86. In the year 2002, what is the difference between the Revenue generated (in %) in Sweden and Revenue generated (in %) in Ukraine?
Provide a short and direct response. 11.93. In the year 2003, what is the difference between the Revenue generated (in %) of High income and Revenue generated (in %) of Greece?
Ensure brevity in your answer.  0.02. In the year 2003, what is the difference between the Revenue generated (in %) in High income and Revenue generated (in %) in Sweden?
Ensure brevity in your answer.  -9.43. In the year 2003, what is the difference between the Revenue generated (in %) in High income and Revenue generated (in %) in Ukraine?
Your response must be concise. 2.94. In the year 2003, what is the difference between the Revenue generated (in %) in Greece and Revenue generated (in %) in Sweden?
Make the answer very short. -9.45. In the year 2003, what is the difference between the Revenue generated (in %) in Greece and Revenue generated (in %) in Ukraine?
Provide a short and direct response. 2.92. In the year 2003, what is the difference between the Revenue generated (in %) in Sweden and Revenue generated (in %) in Ukraine?
Provide a short and direct response. 12.37. In the year 2004, what is the difference between the Revenue generated (in %) of High income and Revenue generated (in %) of Greece?
Provide a succinct answer. 0.15. In the year 2004, what is the difference between the Revenue generated (in %) of High income and Revenue generated (in %) of Sweden?
Your answer should be very brief. -9.29. In the year 2004, what is the difference between the Revenue generated (in %) of High income and Revenue generated (in %) of Ukraine?
Keep it short and to the point. 2.91. In the year 2004, what is the difference between the Revenue generated (in %) of Greece and Revenue generated (in %) of Sweden?
Make the answer very short. -9.44. In the year 2004, what is the difference between the Revenue generated (in %) in Greece and Revenue generated (in %) in Ukraine?
Offer a terse response. 2.76. In the year 2004, what is the difference between the Revenue generated (in %) in Sweden and Revenue generated (in %) in Ukraine?
Your answer should be very brief. 12.2. In the year 2005, what is the difference between the Revenue generated (in %) in High income and Revenue generated (in %) in Greece?
Give a very brief answer. -0.04. In the year 2005, what is the difference between the Revenue generated (in %) in High income and Revenue generated (in %) in Sweden?
Ensure brevity in your answer.  -8.51. In the year 2005, what is the difference between the Revenue generated (in %) in High income and Revenue generated (in %) in Ukraine?
Offer a very short reply. 2.9. In the year 2005, what is the difference between the Revenue generated (in %) in Greece and Revenue generated (in %) in Sweden?
Provide a succinct answer. -8.46. In the year 2005, what is the difference between the Revenue generated (in %) in Greece and Revenue generated (in %) in Ukraine?
Give a very brief answer. 2.94. In the year 2005, what is the difference between the Revenue generated (in %) of Sweden and Revenue generated (in %) of Ukraine?
Ensure brevity in your answer.  11.4. In the year 2006, what is the difference between the Revenue generated (in %) of High income and Revenue generated (in %) of Greece?
Ensure brevity in your answer.  -0.81. In the year 2006, what is the difference between the Revenue generated (in %) of High income and Revenue generated (in %) of Sweden?
Ensure brevity in your answer.  -9.55. In the year 2006, what is the difference between the Revenue generated (in %) in High income and Revenue generated (in %) in Ukraine?
Your response must be concise. 2.96. In the year 2006, what is the difference between the Revenue generated (in %) of Greece and Revenue generated (in %) of Sweden?
Provide a short and direct response. -8.73. In the year 2006, what is the difference between the Revenue generated (in %) in Greece and Revenue generated (in %) in Ukraine?
Your response must be concise. 3.77. In the year 2006, what is the difference between the Revenue generated (in %) in Sweden and Revenue generated (in %) in Ukraine?
Offer a very short reply. 12.5. In the year 2007, what is the difference between the Revenue generated (in %) of High income and Revenue generated (in %) of Greece?
Offer a terse response. -1.32. In the year 2007, what is the difference between the Revenue generated (in %) of High income and Revenue generated (in %) of Sweden?
Ensure brevity in your answer.  -9.52. In the year 2007, what is the difference between the Revenue generated (in %) in High income and Revenue generated (in %) in Ukraine?
Offer a very short reply. 2.39. In the year 2007, what is the difference between the Revenue generated (in %) in Greece and Revenue generated (in %) in Sweden?
Ensure brevity in your answer.  -8.2. In the year 2007, what is the difference between the Revenue generated (in %) in Greece and Revenue generated (in %) in Ukraine?
Give a very brief answer. 3.71. In the year 2007, what is the difference between the Revenue generated (in %) of Sweden and Revenue generated (in %) of Ukraine?
Offer a terse response. 11.91. In the year 2008, what is the difference between the Revenue generated (in %) of High income and Revenue generated (in %) of Greece?
Your answer should be compact. -2.09. In the year 2008, what is the difference between the Revenue generated (in %) in High income and Revenue generated (in %) in Sweden?
Your answer should be very brief. -12.77. In the year 2008, what is the difference between the Revenue generated (in %) of High income and Revenue generated (in %) of Ukraine?
Provide a short and direct response. 1.92. In the year 2008, what is the difference between the Revenue generated (in %) of Greece and Revenue generated (in %) of Sweden?
Your answer should be very brief. -10.67. In the year 2008, what is the difference between the Revenue generated (in %) in Greece and Revenue generated (in %) in Ukraine?
Offer a very short reply. 4.01. In the year 2008, what is the difference between the Revenue generated (in %) in Sweden and Revenue generated (in %) in Ukraine?
Keep it short and to the point. 14.68. What is the ratio of the Revenue generated (in %) of High income in 2001 to that in 2002?
Make the answer very short. 0.75. What is the ratio of the Revenue generated (in %) in Greece in 2001 to that in 2002?
Give a very brief answer. 1.16. What is the ratio of the Revenue generated (in %) of Sweden in 2001 to that in 2002?
Your response must be concise. 0.94. What is the ratio of the Revenue generated (in %) in Ukraine in 2001 to that in 2002?
Offer a terse response. 0.15. What is the ratio of the Revenue generated (in %) of High income in 2001 to that in 2003?
Your answer should be compact. 0.77. What is the ratio of the Revenue generated (in %) in Greece in 2001 to that in 2003?
Offer a very short reply. 1.19. What is the ratio of the Revenue generated (in %) of Sweden in 2001 to that in 2003?
Ensure brevity in your answer.  0.91. What is the ratio of the Revenue generated (in %) of Ukraine in 2001 to that in 2003?
Your answer should be very brief. 0.38. What is the ratio of the Revenue generated (in %) in High income in 2001 to that in 2004?
Offer a very short reply. 0.79. What is the ratio of the Revenue generated (in %) in Greece in 2001 to that in 2004?
Keep it short and to the point. 1.28. What is the ratio of the Revenue generated (in %) in Sweden in 2001 to that in 2004?
Offer a very short reply. 0.93. What is the ratio of the Revenue generated (in %) in Ukraine in 2001 to that in 2004?
Provide a succinct answer. 0.9. What is the ratio of the Revenue generated (in %) of High income in 2001 to that in 2005?
Provide a short and direct response. 0.81. What is the ratio of the Revenue generated (in %) in Greece in 2001 to that in 2005?
Keep it short and to the point. 1.22. What is the ratio of the Revenue generated (in %) in Ukraine in 2001 to that in 2005?
Make the answer very short. 3.95. What is the ratio of the Revenue generated (in %) of High income in 2001 to that in 2006?
Offer a terse response. 0.79. What is the ratio of the Revenue generated (in %) of Greece in 2001 to that in 2006?
Your answer should be compact. 0.95. What is the ratio of the Revenue generated (in %) in Sweden in 2001 to that in 2006?
Offer a very short reply. 0.91. What is the ratio of the Revenue generated (in %) in Ukraine in 2001 to that in 2006?
Offer a very short reply. 8.59. What is the ratio of the Revenue generated (in %) of Greece in 2001 to that in 2007?
Keep it short and to the point. 0.97. What is the ratio of the Revenue generated (in %) of Ukraine in 2001 to that in 2007?
Give a very brief answer. 14.07. What is the ratio of the Revenue generated (in %) in High income in 2001 to that in 2008?
Your answer should be compact. 1.22. What is the ratio of the Revenue generated (in %) of Greece in 2001 to that in 2008?
Keep it short and to the point. 0.9. What is the ratio of the Revenue generated (in %) of Sweden in 2001 to that in 2008?
Make the answer very short. 0.78. What is the ratio of the Revenue generated (in %) in Ukraine in 2001 to that in 2008?
Provide a succinct answer. 36.66. What is the ratio of the Revenue generated (in %) in High income in 2002 to that in 2003?
Keep it short and to the point. 1.02. What is the ratio of the Revenue generated (in %) in Greece in 2002 to that in 2003?
Your answer should be compact. 1.03. What is the ratio of the Revenue generated (in %) of Sweden in 2002 to that in 2003?
Your answer should be very brief. 0.98. What is the ratio of the Revenue generated (in %) of Ukraine in 2002 to that in 2003?
Offer a terse response. 2.54. What is the ratio of the Revenue generated (in %) in High income in 2002 to that in 2004?
Make the answer very short. 1.05. What is the ratio of the Revenue generated (in %) of Greece in 2002 to that in 2004?
Offer a very short reply. 1.11. What is the ratio of the Revenue generated (in %) in Ukraine in 2002 to that in 2004?
Your answer should be very brief. 6. What is the ratio of the Revenue generated (in %) in High income in 2002 to that in 2005?
Your answer should be very brief. 1.07. What is the ratio of the Revenue generated (in %) in Greece in 2002 to that in 2005?
Provide a succinct answer. 1.05. What is the ratio of the Revenue generated (in %) in Sweden in 2002 to that in 2005?
Provide a succinct answer. 1.07. What is the ratio of the Revenue generated (in %) of Ukraine in 2002 to that in 2005?
Provide a succinct answer. 26.3. What is the ratio of the Revenue generated (in %) of High income in 2002 to that in 2006?
Your answer should be very brief. 1.05. What is the ratio of the Revenue generated (in %) of Greece in 2002 to that in 2006?
Give a very brief answer. 0.82. What is the ratio of the Revenue generated (in %) of Sweden in 2002 to that in 2006?
Make the answer very short. 0.97. What is the ratio of the Revenue generated (in %) of Ukraine in 2002 to that in 2006?
Give a very brief answer. 57.21. What is the ratio of the Revenue generated (in %) in High income in 2002 to that in 2007?
Keep it short and to the point. 1.3. What is the ratio of the Revenue generated (in %) of Greece in 2002 to that in 2007?
Keep it short and to the point. 0.84. What is the ratio of the Revenue generated (in %) of Sweden in 2002 to that in 2007?
Offer a very short reply. 1.02. What is the ratio of the Revenue generated (in %) of Ukraine in 2002 to that in 2007?
Your answer should be compact. 93.68. What is the ratio of the Revenue generated (in %) in High income in 2002 to that in 2008?
Your answer should be very brief. 1.62. What is the ratio of the Revenue generated (in %) in Greece in 2002 to that in 2008?
Offer a terse response. 0.77. What is the ratio of the Revenue generated (in %) in Sweden in 2002 to that in 2008?
Your answer should be compact. 0.83. What is the ratio of the Revenue generated (in %) of Ukraine in 2002 to that in 2008?
Your answer should be compact. 244.18. What is the ratio of the Revenue generated (in %) in High income in 2003 to that in 2004?
Provide a succinct answer. 1.03. What is the ratio of the Revenue generated (in %) of Greece in 2003 to that in 2004?
Offer a terse response. 1.08. What is the ratio of the Revenue generated (in %) in Sweden in 2003 to that in 2004?
Your answer should be very brief. 1.02. What is the ratio of the Revenue generated (in %) in Ukraine in 2003 to that in 2004?
Provide a short and direct response. 2.36. What is the ratio of the Revenue generated (in %) of High income in 2003 to that in 2005?
Your answer should be compact. 1.05. What is the ratio of the Revenue generated (in %) of Greece in 2003 to that in 2005?
Offer a very short reply. 1.02. What is the ratio of the Revenue generated (in %) of Sweden in 2003 to that in 2005?
Keep it short and to the point. 1.09. What is the ratio of the Revenue generated (in %) in Ukraine in 2003 to that in 2005?
Your answer should be compact. 10.35. What is the ratio of the Revenue generated (in %) in High income in 2003 to that in 2006?
Keep it short and to the point. 1.03. What is the ratio of the Revenue generated (in %) in Greece in 2003 to that in 2006?
Offer a very short reply. 0.8. What is the ratio of the Revenue generated (in %) of Sweden in 2003 to that in 2006?
Make the answer very short. 1. What is the ratio of the Revenue generated (in %) in Ukraine in 2003 to that in 2006?
Your answer should be very brief. 22.51. What is the ratio of the Revenue generated (in %) in High income in 2003 to that in 2007?
Ensure brevity in your answer.  1.27. What is the ratio of the Revenue generated (in %) in Greece in 2003 to that in 2007?
Keep it short and to the point. 0.81. What is the ratio of the Revenue generated (in %) in Sweden in 2003 to that in 2007?
Your response must be concise. 1.05. What is the ratio of the Revenue generated (in %) in Ukraine in 2003 to that in 2007?
Your answer should be compact. 36.86. What is the ratio of the Revenue generated (in %) of High income in 2003 to that in 2008?
Provide a short and direct response. 1.58. What is the ratio of the Revenue generated (in %) of Greece in 2003 to that in 2008?
Offer a terse response. 0.75. What is the ratio of the Revenue generated (in %) of Sweden in 2003 to that in 2008?
Provide a short and direct response. 0.85. What is the ratio of the Revenue generated (in %) in Ukraine in 2003 to that in 2008?
Keep it short and to the point. 96.07. What is the ratio of the Revenue generated (in %) in High income in 2004 to that in 2005?
Ensure brevity in your answer.  1.02. What is the ratio of the Revenue generated (in %) in Greece in 2004 to that in 2005?
Provide a short and direct response. 0.95. What is the ratio of the Revenue generated (in %) in Sweden in 2004 to that in 2005?
Offer a very short reply. 1.07. What is the ratio of the Revenue generated (in %) in Ukraine in 2004 to that in 2005?
Your answer should be compact. 4.38. What is the ratio of the Revenue generated (in %) in Greece in 2004 to that in 2006?
Provide a short and direct response. 0.74. What is the ratio of the Revenue generated (in %) of Sweden in 2004 to that in 2006?
Make the answer very short. 0.98. What is the ratio of the Revenue generated (in %) of Ukraine in 2004 to that in 2006?
Your response must be concise. 9.53. What is the ratio of the Revenue generated (in %) of High income in 2004 to that in 2007?
Your answer should be compact. 1.23. What is the ratio of the Revenue generated (in %) of Greece in 2004 to that in 2007?
Your response must be concise. 0.75. What is the ratio of the Revenue generated (in %) of Sweden in 2004 to that in 2007?
Your answer should be compact. 1.03. What is the ratio of the Revenue generated (in %) of Ukraine in 2004 to that in 2007?
Your response must be concise. 15.6. What is the ratio of the Revenue generated (in %) of High income in 2004 to that in 2008?
Your response must be concise. 1.54. What is the ratio of the Revenue generated (in %) in Greece in 2004 to that in 2008?
Give a very brief answer. 0.7. What is the ratio of the Revenue generated (in %) of Sweden in 2004 to that in 2008?
Keep it short and to the point. 0.83. What is the ratio of the Revenue generated (in %) in Ukraine in 2004 to that in 2008?
Give a very brief answer. 40.67. What is the ratio of the Revenue generated (in %) in High income in 2005 to that in 2006?
Your response must be concise. 0.98. What is the ratio of the Revenue generated (in %) in Greece in 2005 to that in 2006?
Provide a short and direct response. 0.78. What is the ratio of the Revenue generated (in %) in Sweden in 2005 to that in 2006?
Give a very brief answer. 0.91. What is the ratio of the Revenue generated (in %) of Ukraine in 2005 to that in 2006?
Ensure brevity in your answer.  2.18. What is the ratio of the Revenue generated (in %) in High income in 2005 to that in 2007?
Provide a succinct answer. 1.21. What is the ratio of the Revenue generated (in %) of Greece in 2005 to that in 2007?
Offer a very short reply. 0.79. What is the ratio of the Revenue generated (in %) of Sweden in 2005 to that in 2007?
Ensure brevity in your answer.  0.96. What is the ratio of the Revenue generated (in %) in Ukraine in 2005 to that in 2007?
Provide a short and direct response. 3.56. What is the ratio of the Revenue generated (in %) in High income in 2005 to that in 2008?
Give a very brief answer. 1.51. What is the ratio of the Revenue generated (in %) of Greece in 2005 to that in 2008?
Offer a terse response. 0.73. What is the ratio of the Revenue generated (in %) of Sweden in 2005 to that in 2008?
Ensure brevity in your answer.  0.78. What is the ratio of the Revenue generated (in %) of Ukraine in 2005 to that in 2008?
Make the answer very short. 9.28. What is the ratio of the Revenue generated (in %) in High income in 2006 to that in 2007?
Your response must be concise. 1.24. What is the ratio of the Revenue generated (in %) in Greece in 2006 to that in 2007?
Ensure brevity in your answer.  1.02. What is the ratio of the Revenue generated (in %) of Sweden in 2006 to that in 2007?
Provide a succinct answer. 1.05. What is the ratio of the Revenue generated (in %) in Ukraine in 2006 to that in 2007?
Your response must be concise. 1.64. What is the ratio of the Revenue generated (in %) in High income in 2006 to that in 2008?
Make the answer very short. 1.54. What is the ratio of the Revenue generated (in %) in Greece in 2006 to that in 2008?
Offer a terse response. 0.94. What is the ratio of the Revenue generated (in %) in Sweden in 2006 to that in 2008?
Your answer should be very brief. 0.85. What is the ratio of the Revenue generated (in %) in Ukraine in 2006 to that in 2008?
Give a very brief answer. 4.27. What is the ratio of the Revenue generated (in %) of High income in 2007 to that in 2008?
Provide a succinct answer. 1.25. What is the ratio of the Revenue generated (in %) in Greece in 2007 to that in 2008?
Ensure brevity in your answer.  0.93. What is the ratio of the Revenue generated (in %) in Sweden in 2007 to that in 2008?
Your response must be concise. 0.81. What is the ratio of the Revenue generated (in %) of Ukraine in 2007 to that in 2008?
Ensure brevity in your answer.  2.61. What is the difference between the highest and the second highest Revenue generated (in %) of High income?
Keep it short and to the point. 0.08. What is the difference between the highest and the second highest Revenue generated (in %) in Greece?
Provide a short and direct response. 0.24. What is the difference between the highest and the second highest Revenue generated (in %) in Sweden?
Make the answer very short. 2.18. What is the difference between the highest and the second highest Revenue generated (in %) in Ukraine?
Your response must be concise. 0.15. What is the difference between the highest and the lowest Revenue generated (in %) in High income?
Provide a succinct answer. 1.2. What is the difference between the highest and the lowest Revenue generated (in %) in Greece?
Offer a terse response. 1.21. What is the difference between the highest and the lowest Revenue generated (in %) of Sweden?
Give a very brief answer. 3.28. What is the difference between the highest and the lowest Revenue generated (in %) in Ukraine?
Offer a very short reply. 0.24. 